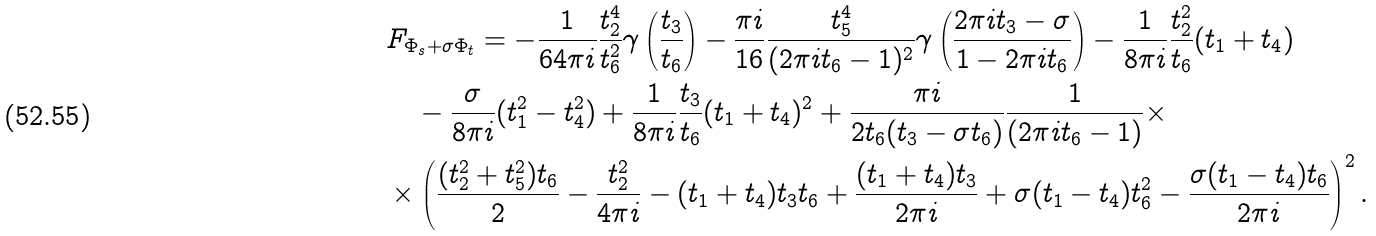<formula> <loc_0><loc_0><loc_500><loc_500>& F _ { \Phi _ { s } + \sigma \Phi _ { t } } = - \frac { 1 } { 6 4 \pi i } \frac { t _ { 2 } ^ { 4 } } { t _ { 6 } ^ { 2 } } \gamma \left ( \frac { t _ { 3 } } { t _ { 6 } } \right ) - \frac { \pi i } { 1 6 } \frac { t _ { 5 } ^ { 4 } } { ( 2 \pi i t _ { 6 } - 1 ) ^ { 2 } } \gamma \left ( \frac { 2 \pi i t _ { 3 } - \sigma } { 1 - 2 \pi i t _ { 6 } } \right ) - \frac { 1 } { 8 \pi i } \frac { t _ { 2 } ^ { 2 } } { t _ { 6 } } ( t _ { 1 } + t _ { 4 } ) \\ & \quad - \frac { \sigma } { 8 \pi i } ( t _ { 1 } ^ { 2 } - t _ { 4 } ^ { 2 } ) + \frac { 1 } { 8 \pi i } \frac { t _ { 3 } } { t _ { 6 } } ( t _ { 1 } + t _ { 4 } ) ^ { 2 } + \frac { \pi i } { 2 t _ { 6 } ( t _ { 3 } - \sigma t _ { 6 } ) } \frac { 1 } { ( 2 \pi i t _ { 6 } - 1 ) } \times \\ & \times \left ( \frac { ( t _ { 2 } ^ { 2 } + t _ { 5 } ^ { 2 } ) t _ { 6 } } { 2 } - \frac { t _ { 2 } ^ { 2 } } { 4 \pi i } - ( t _ { 1 } + t _ { 4 } ) t _ { 3 } t _ { 6 } + \frac { ( t _ { 1 } + t _ { 4 } ) t _ { 3 } } { 2 \pi i } + \sigma ( t _ { 1 } - t _ { 4 } ) t _ { 6 } ^ { 2 } - \frac { \sigma ( t _ { 1 } - t _ { 4 } ) t _ { 6 } } { 2 \pi i } \right ) ^ { 2 } .</formula> 